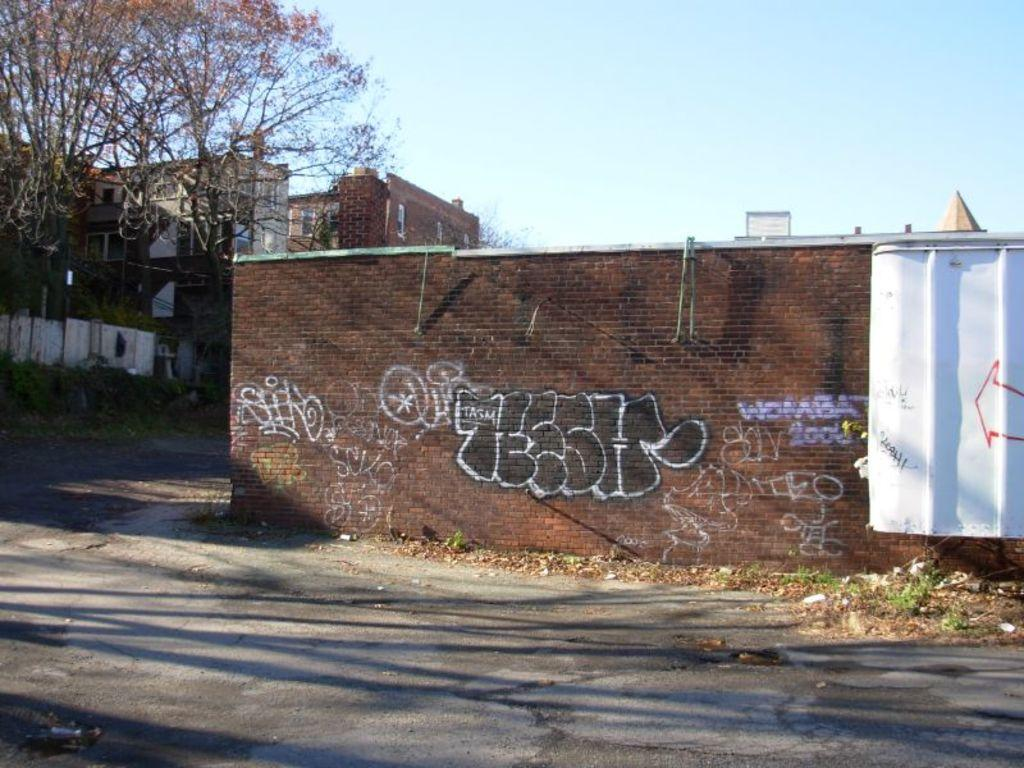What type of natural elements can be seen in the image? There are trees in the image. What type of man-made structures are present in the image? There are buildings in the image. What is the primary mode of transportation visible in the image? There is a road at the bottom of the image. What is the average income of the dogs in the image? There are no dogs present in the image, so it is not possible to determine their average income. 